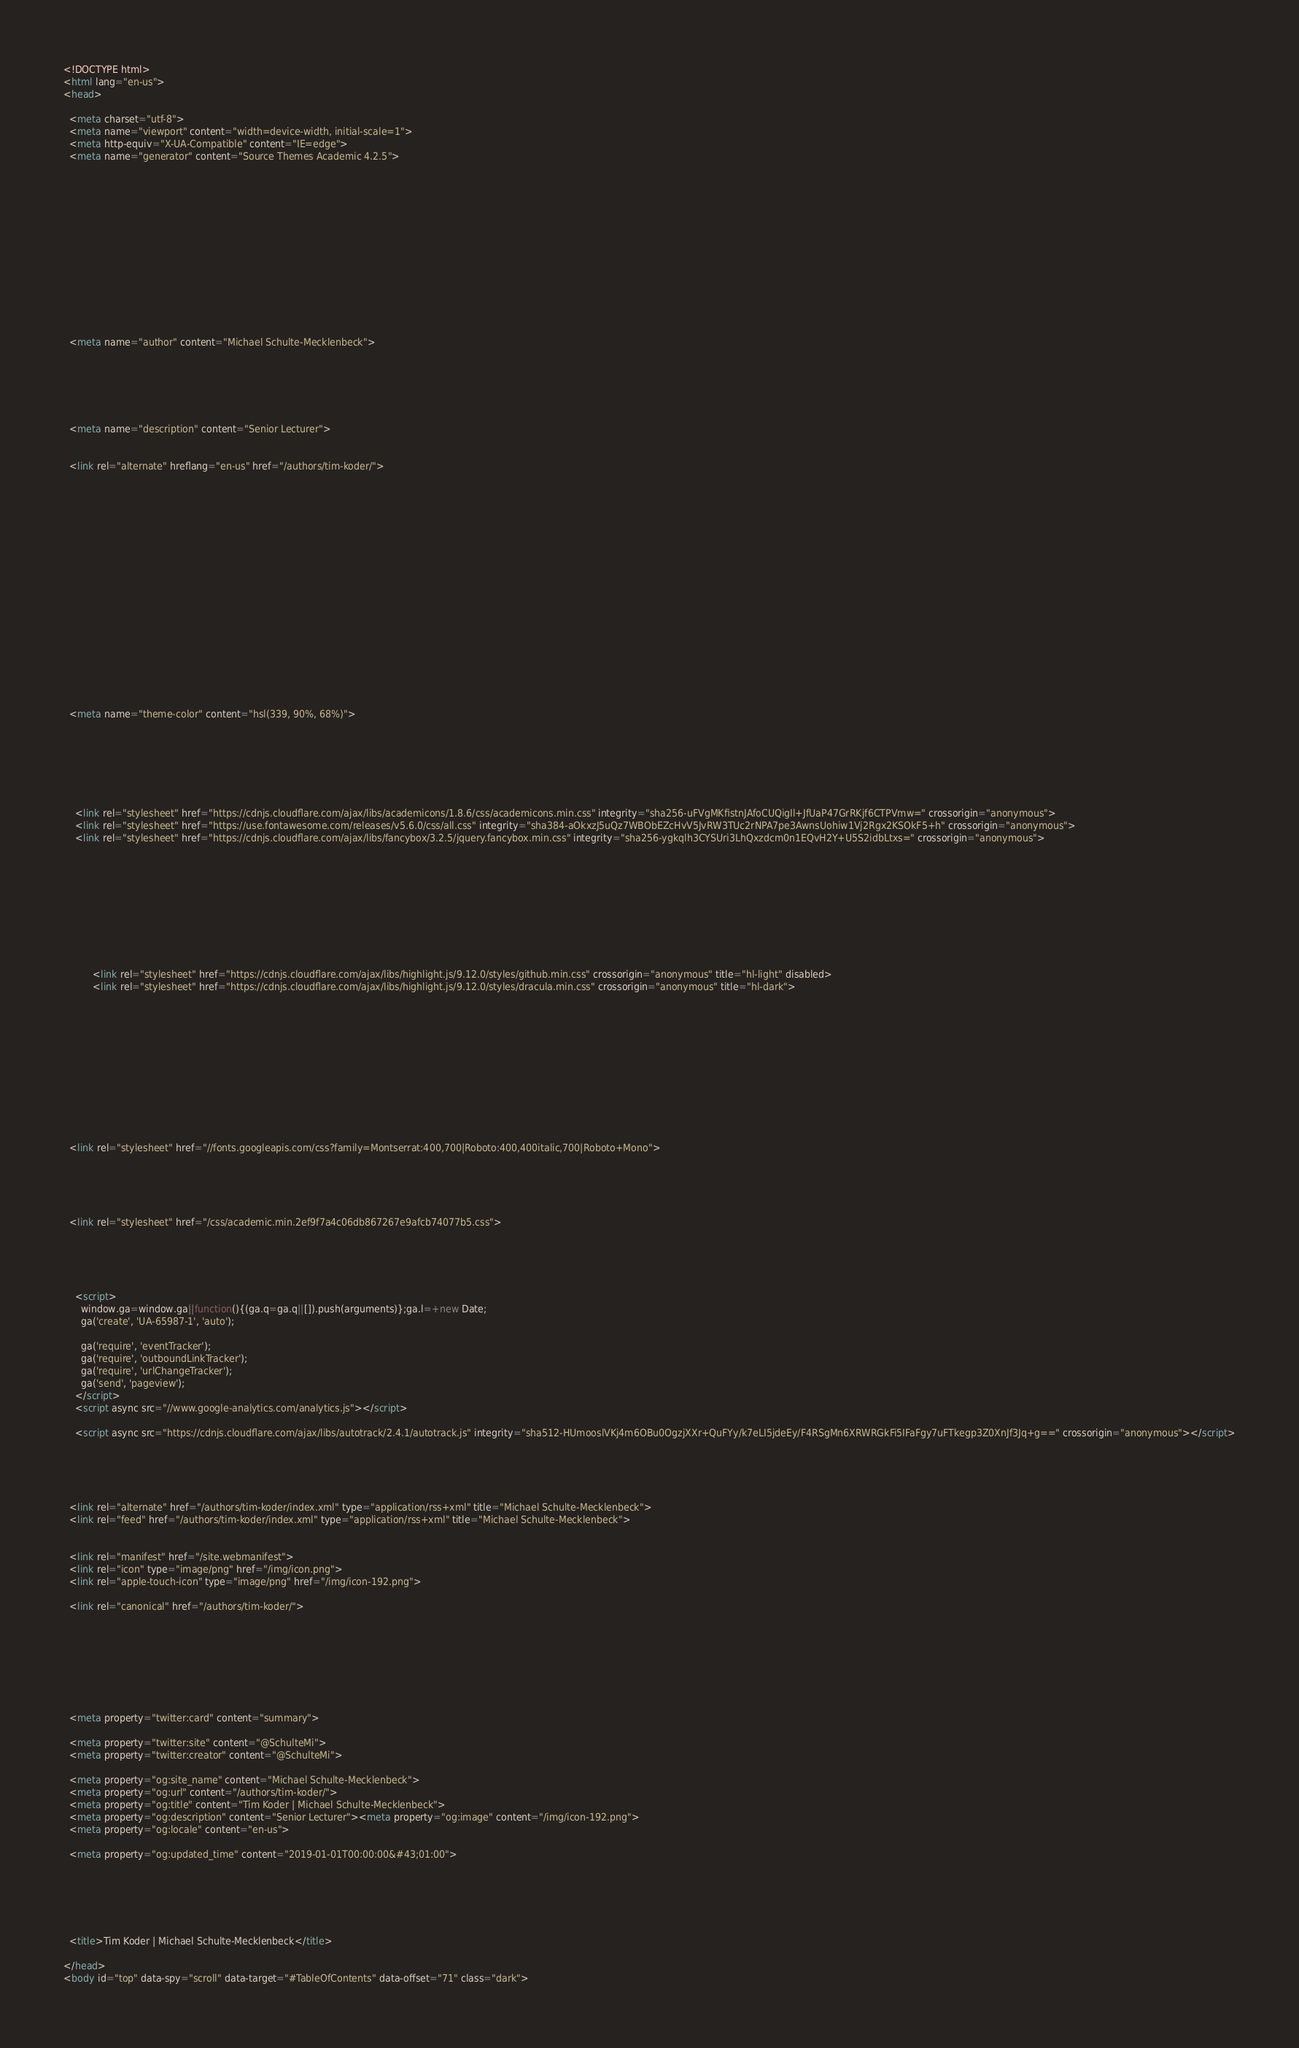<code> <loc_0><loc_0><loc_500><loc_500><_HTML_><!DOCTYPE html>
<html lang="en-us">
<head>

  <meta charset="utf-8">
  <meta name="viewport" content="width=device-width, initial-scale=1">
  <meta http-equiv="X-UA-Compatible" content="IE=edge">
  <meta name="generator" content="Source Themes Academic 4.2.5">

  

  
  
  
  
  
    
    
    
  
  

  <meta name="author" content="Michael Schulte-Mecklenbeck">

  
  
  
    
  
  <meta name="description" content="Senior Lecturer">

  
  <link rel="alternate" hreflang="en-us" href="/authors/tim-koder/">

  


  

  

  

  

  

  

  
  
  
  <meta name="theme-color" content="hsl(339, 90%, 68%)">
  

  
  
  
  
    
    <link rel="stylesheet" href="https://cdnjs.cloudflare.com/ajax/libs/academicons/1.8.6/css/academicons.min.css" integrity="sha256-uFVgMKfistnJAfoCUQigIl+JfUaP47GrRKjf6CTPVmw=" crossorigin="anonymous">
    <link rel="stylesheet" href="https://use.fontawesome.com/releases/v5.6.0/css/all.css" integrity="sha384-aOkxzJ5uQz7WBObEZcHvV5JvRW3TUc2rNPA7pe3AwnsUohiw1Vj2Rgx2KSOkF5+h" crossorigin="anonymous">
    <link rel="stylesheet" href="https://cdnjs.cloudflare.com/ajax/libs/fancybox/3.2.5/jquery.fancybox.min.css" integrity="sha256-ygkqlh3CYSUri3LhQxzdcm0n1EQvH2Y+U5S2idbLtxs=" crossorigin="anonymous">

    
    
    
      
    
    
      
      
        
          <link rel="stylesheet" href="https://cdnjs.cloudflare.com/ajax/libs/highlight.js/9.12.0/styles/github.min.css" crossorigin="anonymous" title="hl-light" disabled>
          <link rel="stylesheet" href="https://cdnjs.cloudflare.com/ajax/libs/highlight.js/9.12.0/styles/dracula.min.css" crossorigin="anonymous" title="hl-dark">
        
      
    

    

    

  

  
  
  <link rel="stylesheet" href="//fonts.googleapis.com/css?family=Montserrat:400,700|Roboto:400,400italic,700|Roboto+Mono">
  

  
  
  
  <link rel="stylesheet" href="/css/academic.min.2ef9f7a4c06db867267e9afcb74077b5.css">

  

  
  
    <script>
      window.ga=window.ga||function(){(ga.q=ga.q||[]).push(arguments)};ga.l=+new Date;
      ga('create', 'UA-65987-1', 'auto');
      
      ga('require', 'eventTracker');
      ga('require', 'outboundLinkTracker');
      ga('require', 'urlChangeTracker');
      ga('send', 'pageview');
    </script>
    <script async src="//www.google-analytics.com/analytics.js"></script>
    
    <script async src="https://cdnjs.cloudflare.com/ajax/libs/autotrack/2.4.1/autotrack.js" integrity="sha512-HUmooslVKj4m6OBu0OgzjXXr+QuFYy/k7eLI5jdeEy/F4RSgMn6XRWRGkFi5IFaFgy7uFTkegp3Z0XnJf3Jq+g==" crossorigin="anonymous"></script>
    
  
  

  
  <link rel="alternate" href="/authors/tim-koder/index.xml" type="application/rss+xml" title="Michael Schulte-Mecklenbeck">
  <link rel="feed" href="/authors/tim-koder/index.xml" type="application/rss+xml" title="Michael Schulte-Mecklenbeck">
  

  <link rel="manifest" href="/site.webmanifest">
  <link rel="icon" type="image/png" href="/img/icon.png">
  <link rel="apple-touch-icon" type="image/png" href="/img/icon-192.png">

  <link rel="canonical" href="/authors/tim-koder/">

  
  
  
  
    
    
  
  <meta property="twitter:card" content="summary">
  
  <meta property="twitter:site" content="@SchulteMi">
  <meta property="twitter:creator" content="@SchulteMi">
  
  <meta property="og:site_name" content="Michael Schulte-Mecklenbeck">
  <meta property="og:url" content="/authors/tim-koder/">
  <meta property="og:title" content="Tim Koder | Michael Schulte-Mecklenbeck">
  <meta property="og:description" content="Senior Lecturer"><meta property="og:image" content="/img/icon-192.png">
  <meta property="og:locale" content="en-us">
  
  <meta property="og:updated_time" content="2019-01-01T00:00:00&#43;01:00">
  

  

  

  <title>Tim Koder | Michael Schulte-Mecklenbeck</title>

</head>
<body id="top" data-spy="scroll" data-target="#TableOfContents" data-offset="71" class="dark"></code> 